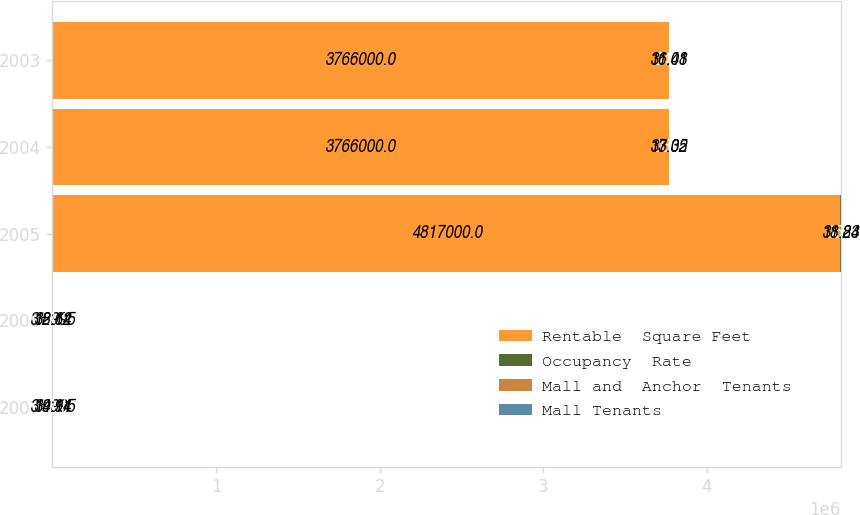Convert chart. <chart><loc_0><loc_0><loc_500><loc_500><stacked_bar_chart><ecel><fcel>2007<fcel>2006<fcel>2005<fcel>2004<fcel>2003<nl><fcel>Rentable  Square Feet<fcel>33.995<fcel>33.995<fcel>4.817e+06<fcel>3.766e+06<fcel>3.766e+06<nl><fcel>Occupancy  Rate<fcel>96.1<fcel>93.4<fcel>96.2<fcel>93.1<fcel>94.1<nl><fcel>Mall and  Anchor  Tenants<fcel>34.94<fcel>32.64<fcel>31.83<fcel>33.05<fcel>31.08<nl><fcel>Mall Tenants<fcel>19.11<fcel>18.12<fcel>18.24<fcel>17.32<fcel>16.41<nl></chart> 